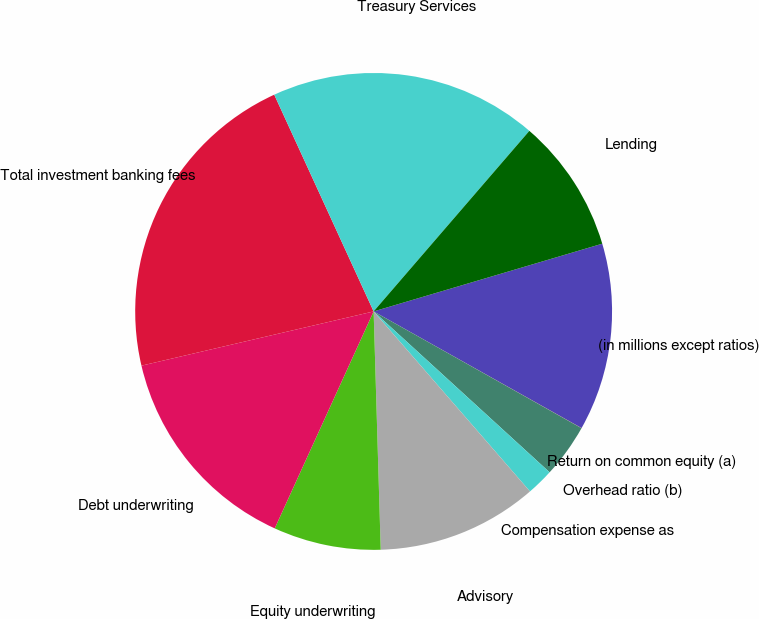Convert chart to OTSL. <chart><loc_0><loc_0><loc_500><loc_500><pie_chart><fcel>(in millions except ratios)<fcel>Return on common equity (a)<fcel>Overhead ratio (b)<fcel>Compensation expense as<fcel>Advisory<fcel>Equity underwriting<fcel>Debt underwriting<fcel>Total investment banking fees<fcel>Treasury Services<fcel>Lending<nl><fcel>12.72%<fcel>0.01%<fcel>3.64%<fcel>1.83%<fcel>10.91%<fcel>7.28%<fcel>14.54%<fcel>21.81%<fcel>18.17%<fcel>9.09%<nl></chart> 